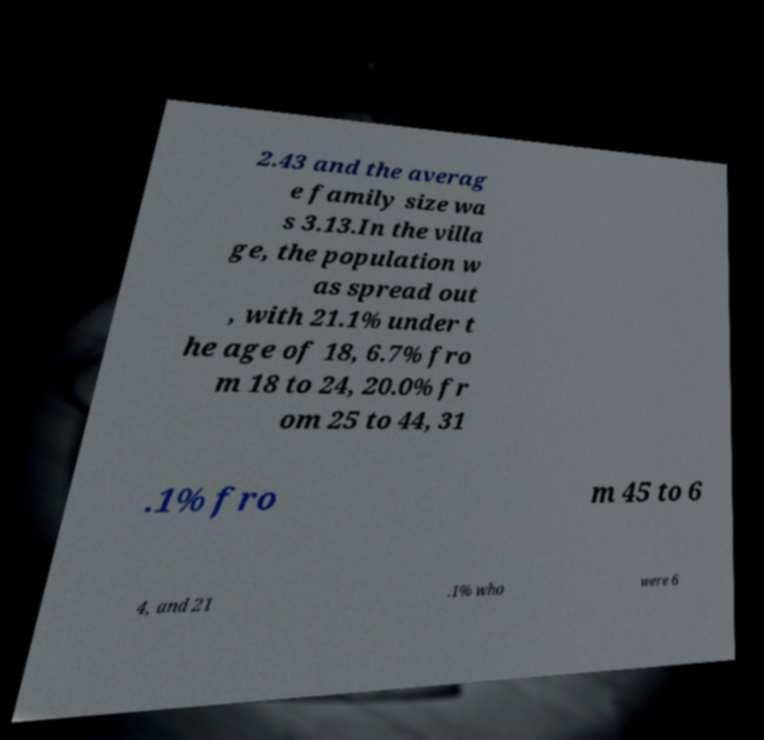There's text embedded in this image that I need extracted. Can you transcribe it verbatim? 2.43 and the averag e family size wa s 3.13.In the villa ge, the population w as spread out , with 21.1% under t he age of 18, 6.7% fro m 18 to 24, 20.0% fr om 25 to 44, 31 .1% fro m 45 to 6 4, and 21 .1% who were 6 